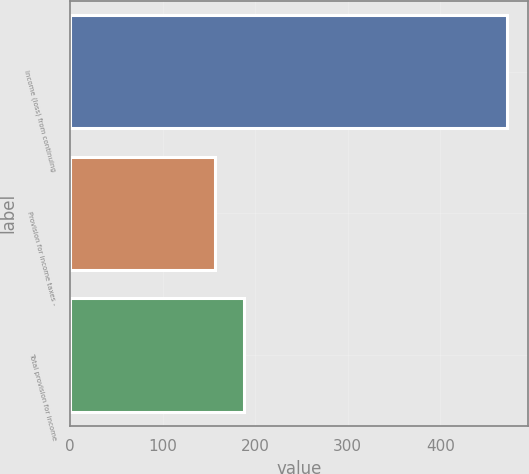Convert chart to OTSL. <chart><loc_0><loc_0><loc_500><loc_500><bar_chart><fcel>Income (loss) from continuing<fcel>Provision for income taxes -<fcel>Total provision for income<nl><fcel>471.5<fcel>156.6<fcel>188.09<nl></chart> 